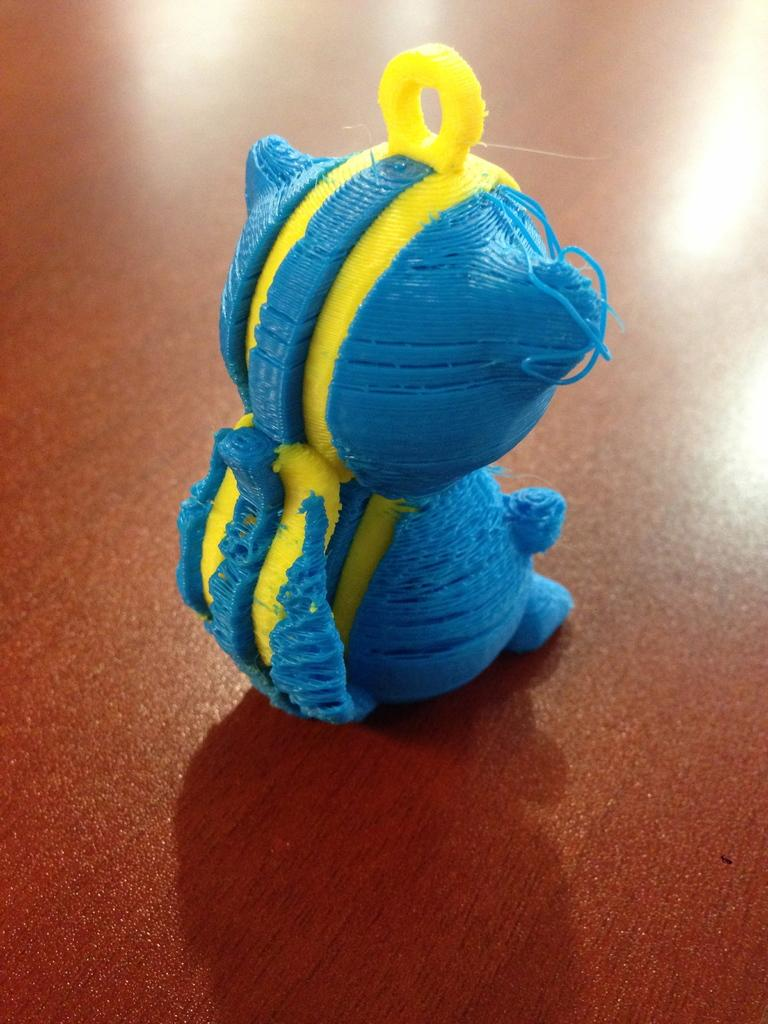What object can be seen in the image? There is a toy in the image. Where is the toy located? The toy is placed on a table. What type of wine is being served to the visitor in the image? There is no visitor or wine present in the image; it only features a toy placed on a table. 